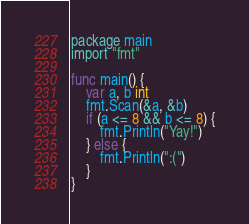<code> <loc_0><loc_0><loc_500><loc_500><_Go_>package main
import "fmt"

func main() {
	var a, b int
	fmt.Scan(&a, &b)
	if (a <= 8 && b <= 8) {
		fmt.Println("Yay!")
	} else {
		fmt.Println(":(")
	}
}
</code> 